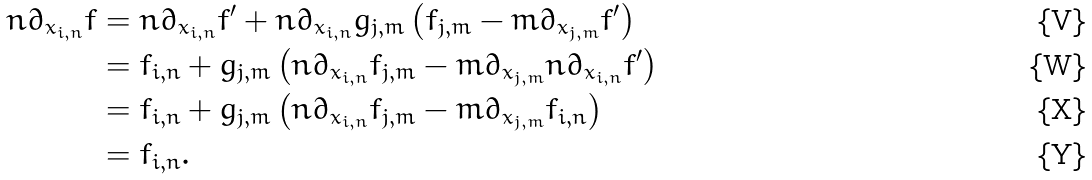Convert formula to latex. <formula><loc_0><loc_0><loc_500><loc_500>n \partial _ { x _ { i , n } } f & = n \partial _ { x _ { i , n } } f ^ { \prime } + n \partial _ { x _ { i , n } } g _ { j , m } \left ( f _ { j , m } - m \partial _ { x _ { j , m } } f ^ { \prime } \right ) \\ & = f _ { i , n } + g _ { j , m } \left ( n \partial _ { x _ { i , n } } f _ { j , m } - m \partial _ { x _ { j , m } } n \partial _ { x _ { i , n } } f ^ { \prime } \right ) \\ & = f _ { i , n } + g _ { j , m } \left ( n \partial _ { x _ { i , n } } f _ { j , m } - m \partial _ { x _ { j , m } } f _ { i , n } \right ) \\ & = f _ { i , n } .</formula> 